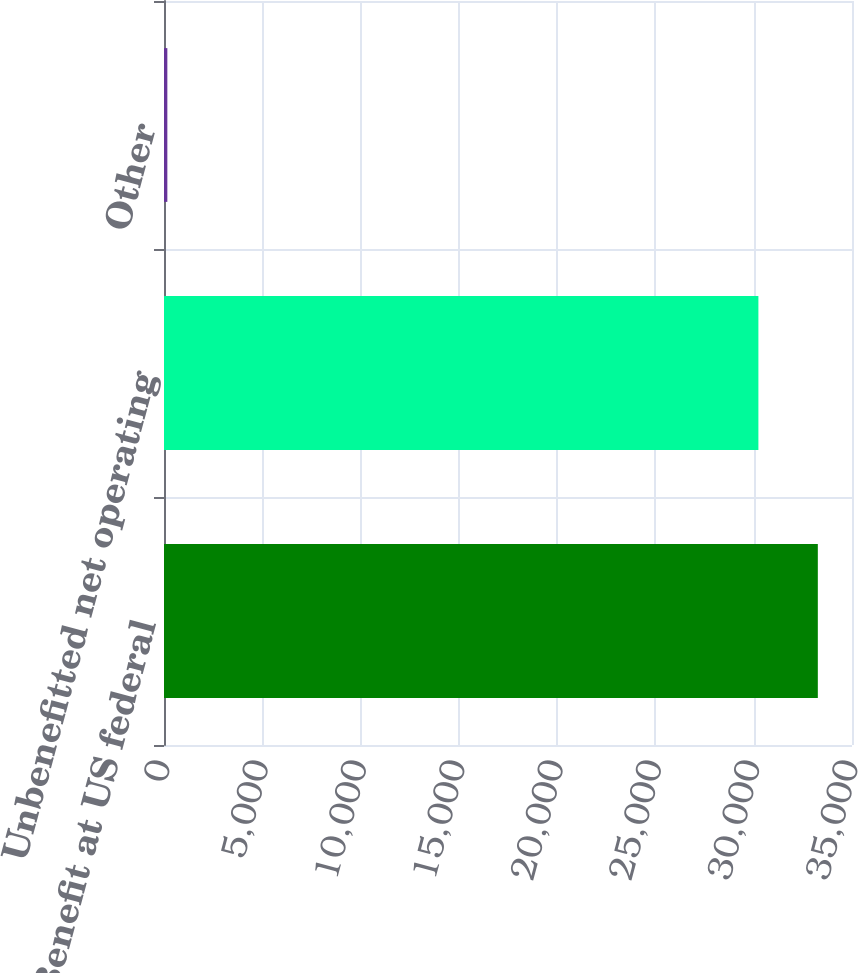Convert chart. <chart><loc_0><loc_0><loc_500><loc_500><bar_chart><fcel>Benefit at US federal<fcel>Unbenefitted net operating<fcel>Other<nl><fcel>33261.8<fcel>30238<fcel>170<nl></chart> 